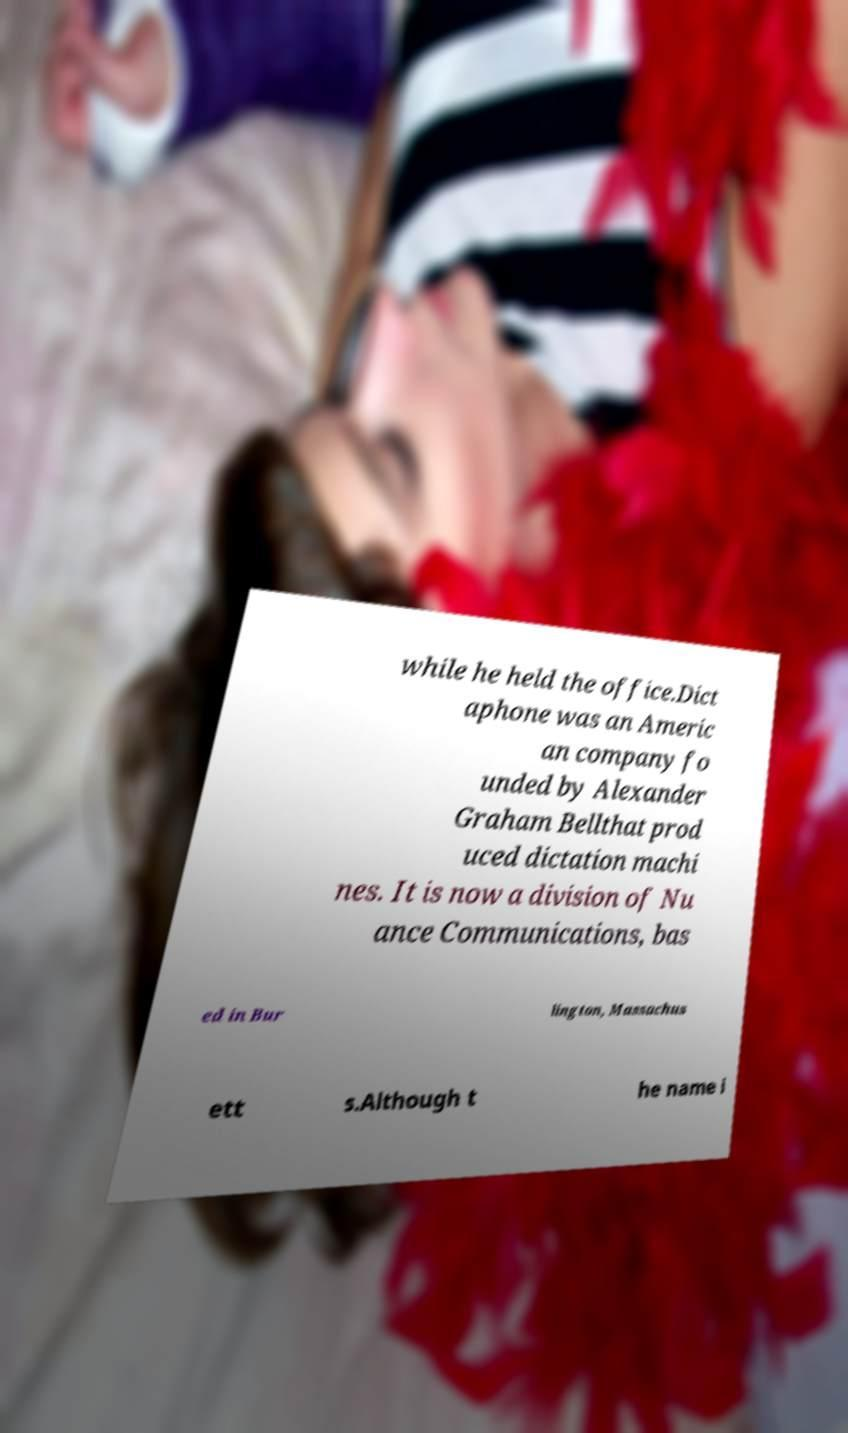Could you extract and type out the text from this image? while he held the office.Dict aphone was an Americ an company fo unded by Alexander Graham Bellthat prod uced dictation machi nes. It is now a division of Nu ance Communications, bas ed in Bur lington, Massachus ett s.Although t he name i 